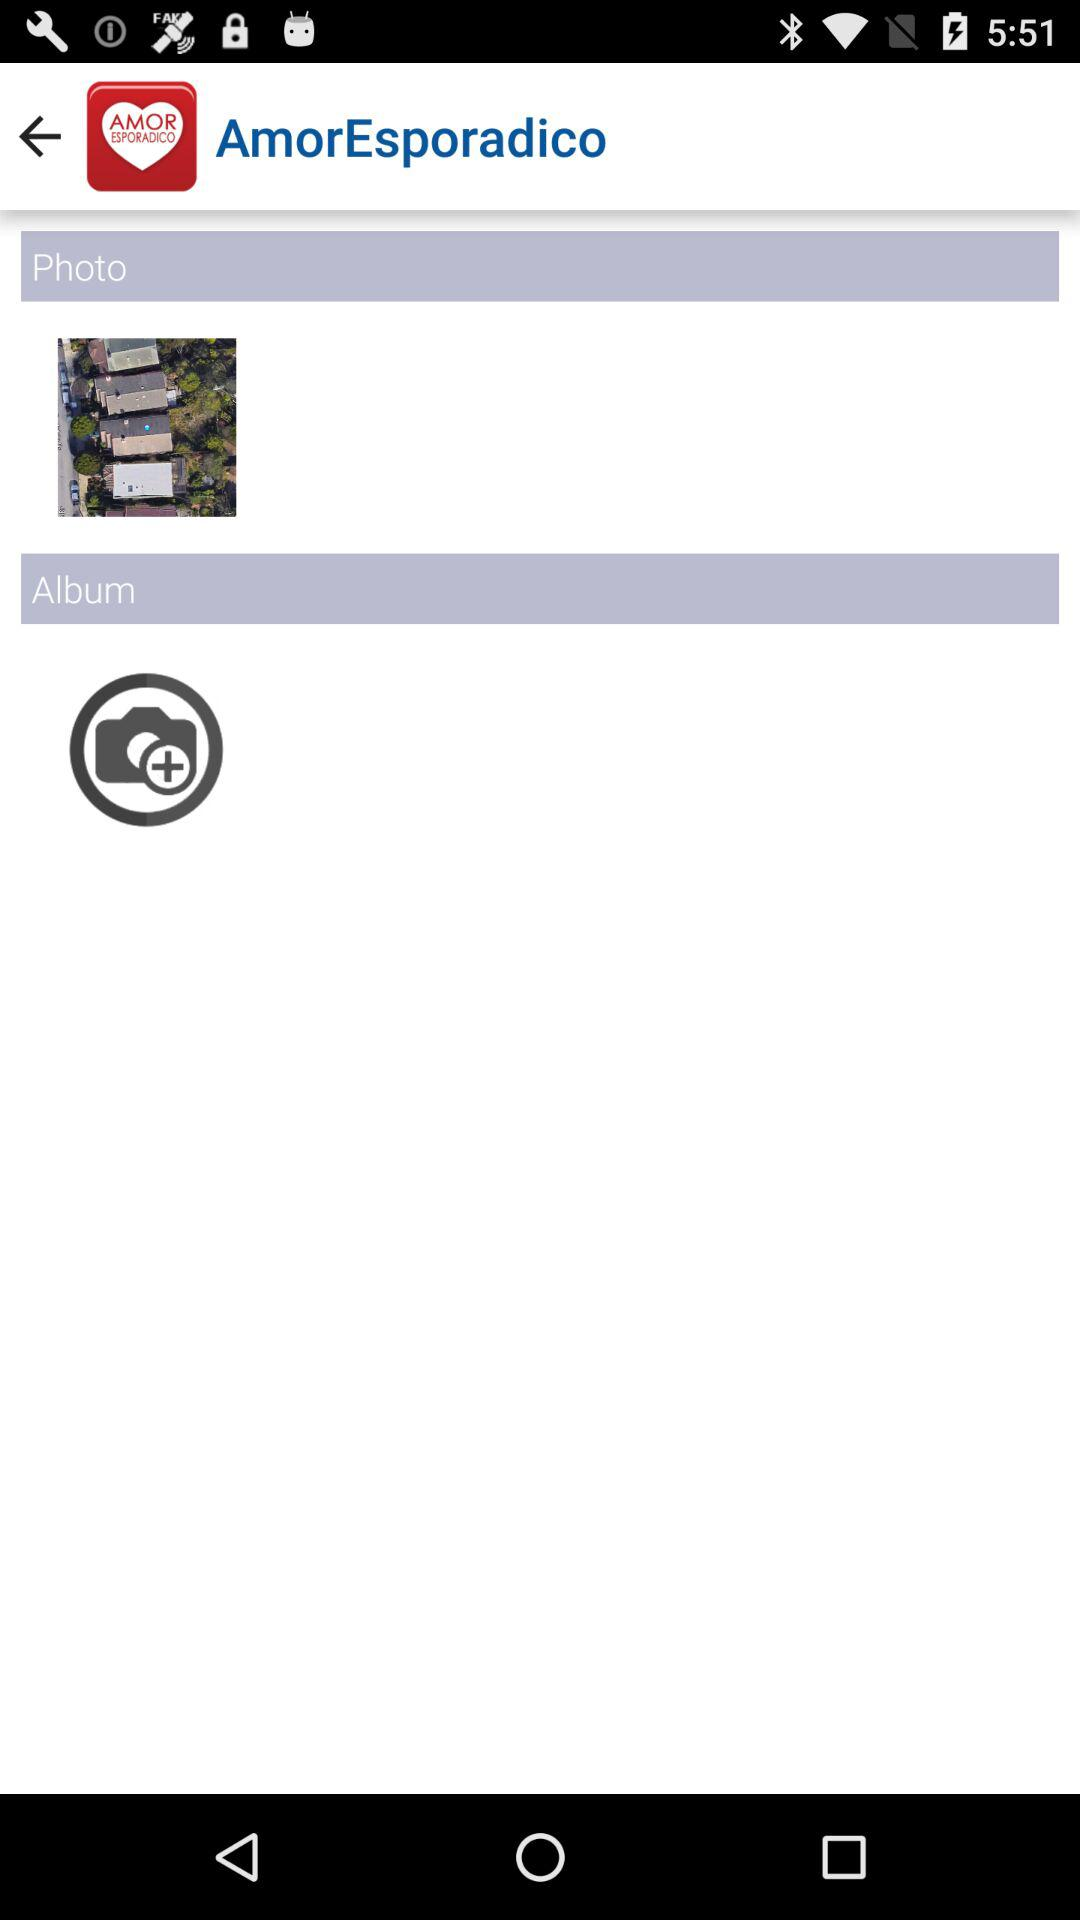Who posted the photo?
When the provided information is insufficient, respond with <no answer>. <no answer> 